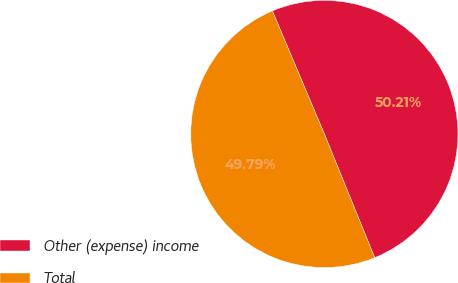<chart> <loc_0><loc_0><loc_500><loc_500><pie_chart><fcel>Other (expense) income<fcel>Total<nl><fcel>50.21%<fcel>49.79%<nl></chart> 